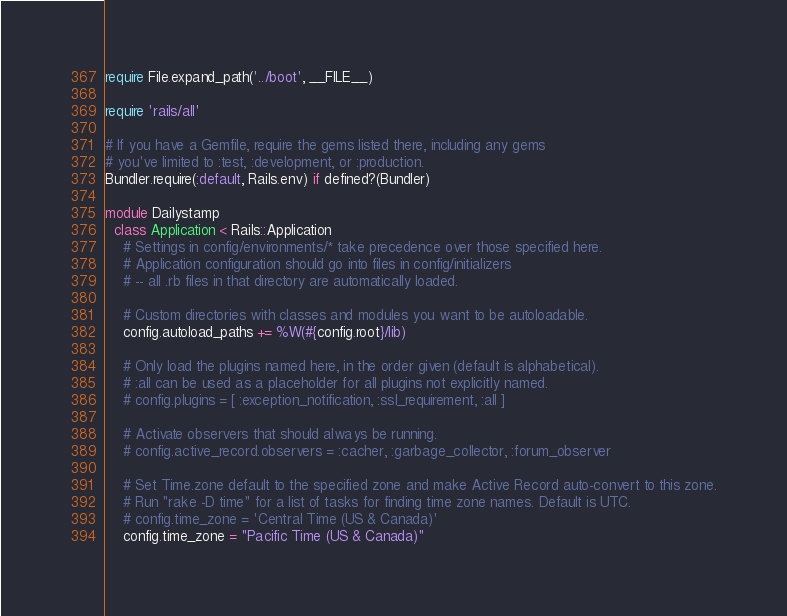Convert code to text. <code><loc_0><loc_0><loc_500><loc_500><_Ruby_>require File.expand_path('../boot', __FILE__)

require 'rails/all'

# If you have a Gemfile, require the gems listed there, including any gems
# you've limited to :test, :development, or :production.
Bundler.require(:default, Rails.env) if defined?(Bundler)

module Dailystamp
  class Application < Rails::Application
    # Settings in config/environments/* take precedence over those specified here.
    # Application configuration should go into files in config/initializers
    # -- all .rb files in that directory are automatically loaded.

    # Custom directories with classes and modules you want to be autoloadable.
    config.autoload_paths += %W(#{config.root}/lib)

    # Only load the plugins named here, in the order given (default is alphabetical).
    # :all can be used as a placeholder for all plugins not explicitly named.
    # config.plugins = [ :exception_notification, :ssl_requirement, :all ]

    # Activate observers that should always be running.
    # config.active_record.observers = :cacher, :garbage_collector, :forum_observer

    # Set Time.zone default to the specified zone and make Active Record auto-convert to this zone.
    # Run "rake -D time" for a list of tasks for finding time zone names. Default is UTC.
    # config.time_zone = 'Central Time (US & Canada)'
    config.time_zone = "Pacific Time (US & Canada)"
</code> 